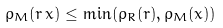<formula> <loc_0><loc_0><loc_500><loc_500>\rho _ { M } ( r \, x ) \leq \min ( \rho _ { R } ( r ) , \rho _ { M } ( x ) )</formula> 